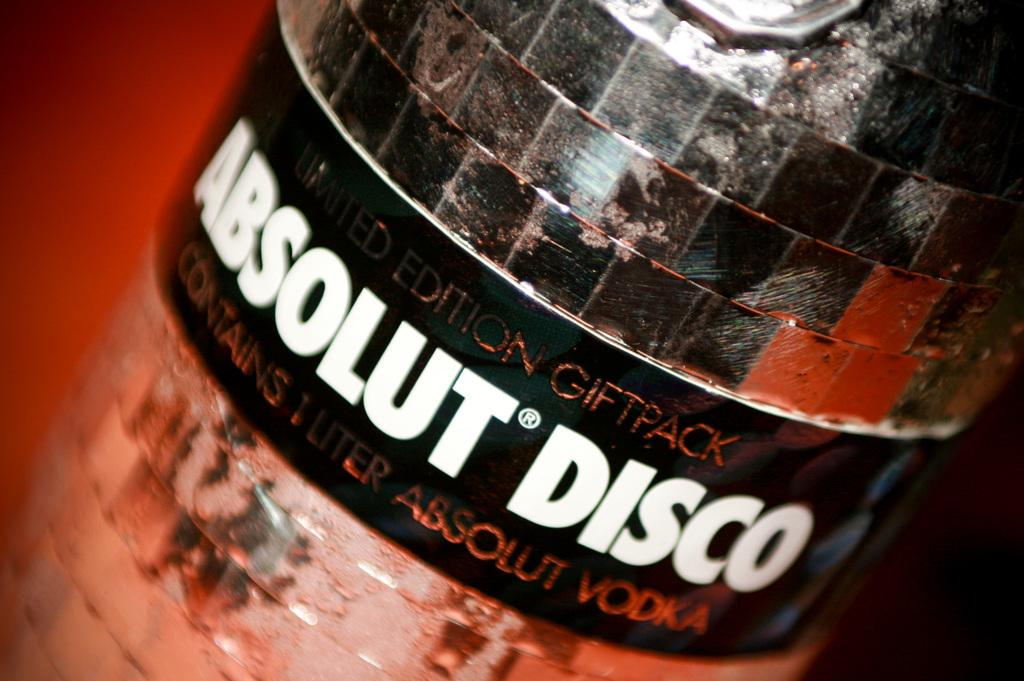<image>
Relay a brief, clear account of the picture shown. A closeup of a bottle of Absolut Disco vodka 